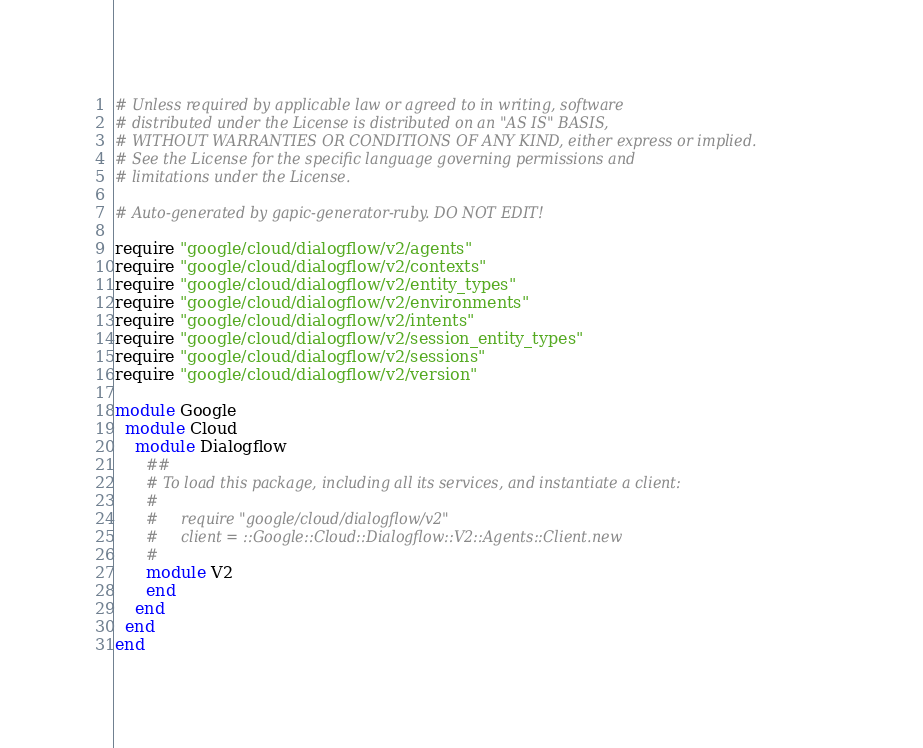Convert code to text. <code><loc_0><loc_0><loc_500><loc_500><_Ruby_># Unless required by applicable law or agreed to in writing, software
# distributed under the License is distributed on an "AS IS" BASIS,
# WITHOUT WARRANTIES OR CONDITIONS OF ANY KIND, either express or implied.
# See the License for the specific language governing permissions and
# limitations under the License.

# Auto-generated by gapic-generator-ruby. DO NOT EDIT!

require "google/cloud/dialogflow/v2/agents"
require "google/cloud/dialogflow/v2/contexts"
require "google/cloud/dialogflow/v2/entity_types"
require "google/cloud/dialogflow/v2/environments"
require "google/cloud/dialogflow/v2/intents"
require "google/cloud/dialogflow/v2/session_entity_types"
require "google/cloud/dialogflow/v2/sessions"
require "google/cloud/dialogflow/v2/version"

module Google
  module Cloud
    module Dialogflow
      ##
      # To load this package, including all its services, and instantiate a client:
      #
      #     require "google/cloud/dialogflow/v2"
      #     client = ::Google::Cloud::Dialogflow::V2::Agents::Client.new
      #
      module V2
      end
    end
  end
end
</code> 